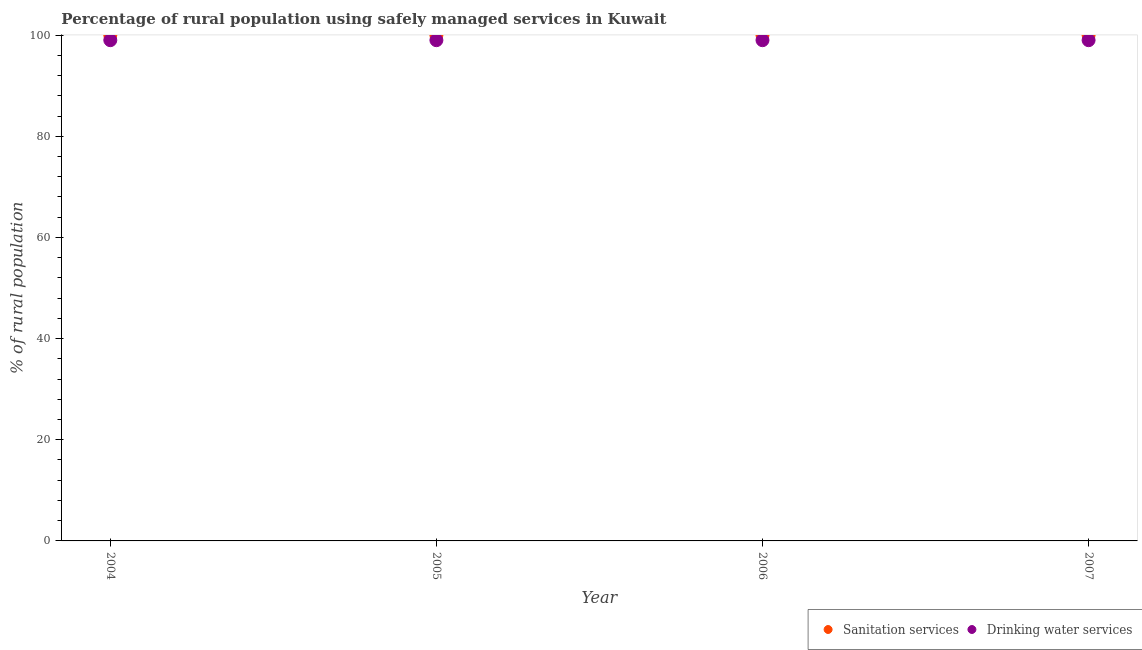What is the percentage of rural population who used drinking water services in 2005?
Make the answer very short. 99. Across all years, what is the maximum percentage of rural population who used drinking water services?
Provide a short and direct response. 99. Across all years, what is the minimum percentage of rural population who used sanitation services?
Your response must be concise. 100. In which year was the percentage of rural population who used drinking water services maximum?
Offer a terse response. 2004. In which year was the percentage of rural population who used sanitation services minimum?
Your answer should be compact. 2004. What is the total percentage of rural population who used sanitation services in the graph?
Your response must be concise. 400. What is the difference between the percentage of rural population who used drinking water services in 2006 and the percentage of rural population who used sanitation services in 2004?
Make the answer very short. -1. In the year 2006, what is the difference between the percentage of rural population who used sanitation services and percentage of rural population who used drinking water services?
Provide a succinct answer. 1. What is the ratio of the percentage of rural population who used drinking water services in 2006 to that in 2007?
Offer a terse response. 1. Is the percentage of rural population who used drinking water services in 2004 less than that in 2007?
Give a very brief answer. No. What is the difference between the highest and the second highest percentage of rural population who used sanitation services?
Your answer should be compact. 0. In how many years, is the percentage of rural population who used drinking water services greater than the average percentage of rural population who used drinking water services taken over all years?
Provide a short and direct response. 0. Is the sum of the percentage of rural population who used sanitation services in 2004 and 2006 greater than the maximum percentage of rural population who used drinking water services across all years?
Offer a very short reply. Yes. How many years are there in the graph?
Provide a succinct answer. 4. What is the difference between two consecutive major ticks on the Y-axis?
Keep it short and to the point. 20. Are the values on the major ticks of Y-axis written in scientific E-notation?
Your response must be concise. No. Does the graph contain any zero values?
Your answer should be very brief. No. How are the legend labels stacked?
Give a very brief answer. Horizontal. What is the title of the graph?
Your response must be concise. Percentage of rural population using safely managed services in Kuwait. What is the label or title of the X-axis?
Give a very brief answer. Year. What is the label or title of the Y-axis?
Offer a very short reply. % of rural population. What is the % of rural population in Drinking water services in 2004?
Make the answer very short. 99. What is the % of rural population of Drinking water services in 2005?
Provide a short and direct response. 99. What is the % of rural population of Drinking water services in 2006?
Your answer should be very brief. 99. Across all years, what is the minimum % of rural population of Sanitation services?
Offer a very short reply. 100. What is the total % of rural population in Drinking water services in the graph?
Offer a very short reply. 396. What is the difference between the % of rural population in Drinking water services in 2004 and that in 2005?
Provide a succinct answer. 0. What is the difference between the % of rural population in Drinking water services in 2004 and that in 2006?
Provide a succinct answer. 0. What is the difference between the % of rural population of Drinking water services in 2004 and that in 2007?
Provide a short and direct response. 0. What is the difference between the % of rural population of Drinking water services in 2005 and that in 2006?
Keep it short and to the point. 0. What is the difference between the % of rural population of Sanitation services in 2005 and that in 2007?
Offer a terse response. 0. What is the difference between the % of rural population in Sanitation services in 2004 and the % of rural population in Drinking water services in 2007?
Offer a very short reply. 1. What is the difference between the % of rural population in Sanitation services in 2005 and the % of rural population in Drinking water services in 2006?
Provide a succinct answer. 1. What is the difference between the % of rural population of Sanitation services in 2006 and the % of rural population of Drinking water services in 2007?
Your response must be concise. 1. What is the average % of rural population of Sanitation services per year?
Keep it short and to the point. 100. What is the average % of rural population in Drinking water services per year?
Offer a terse response. 99. In the year 2006, what is the difference between the % of rural population in Sanitation services and % of rural population in Drinking water services?
Offer a very short reply. 1. What is the ratio of the % of rural population in Drinking water services in 2004 to that in 2005?
Give a very brief answer. 1. What is the ratio of the % of rural population of Drinking water services in 2004 to that in 2007?
Your answer should be very brief. 1. What is the ratio of the % of rural population in Sanitation services in 2005 to that in 2006?
Keep it short and to the point. 1. What is the ratio of the % of rural population in Sanitation services in 2005 to that in 2007?
Provide a short and direct response. 1. What is the ratio of the % of rural population in Sanitation services in 2006 to that in 2007?
Give a very brief answer. 1. What is the ratio of the % of rural population in Drinking water services in 2006 to that in 2007?
Make the answer very short. 1. What is the difference between the highest and the second highest % of rural population in Sanitation services?
Your answer should be very brief. 0. What is the difference between the highest and the lowest % of rural population in Sanitation services?
Provide a succinct answer. 0. 